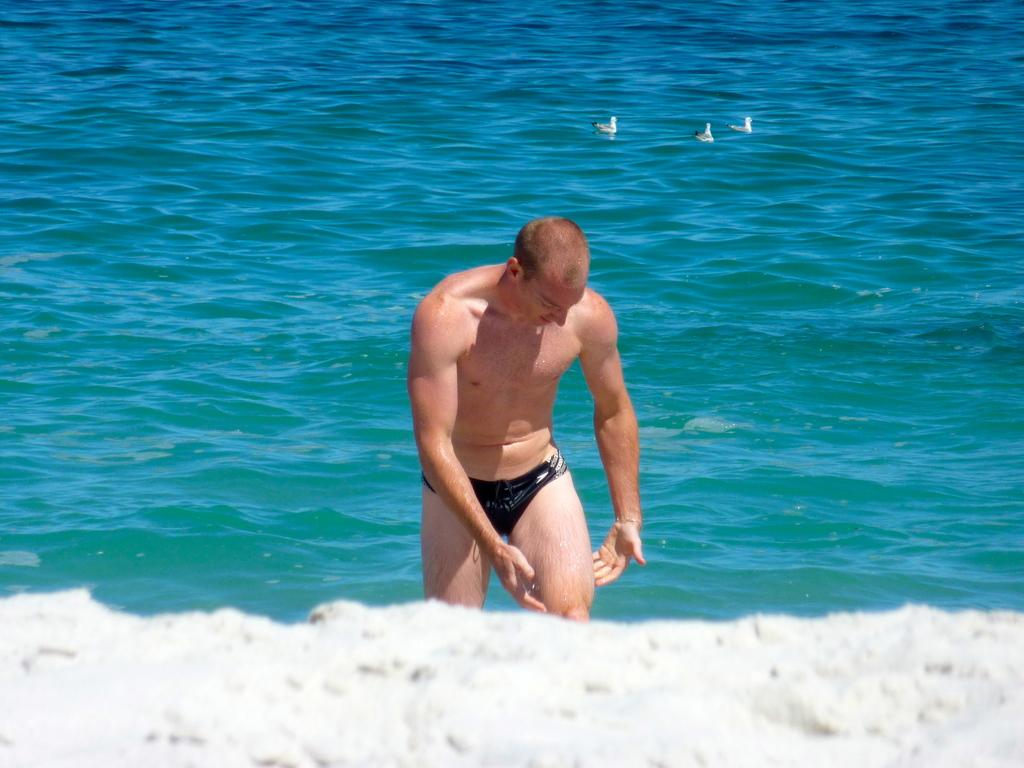Who or what is present in the image? There is a person in the image. Where is the person located? The person is on the sea shore. What else can be seen in the water in the image? There are birds in the water in the image. What type of pie is being served on the beach in the image? There is no pie present in the image; it features a person on the sea shore and birds in the water. 